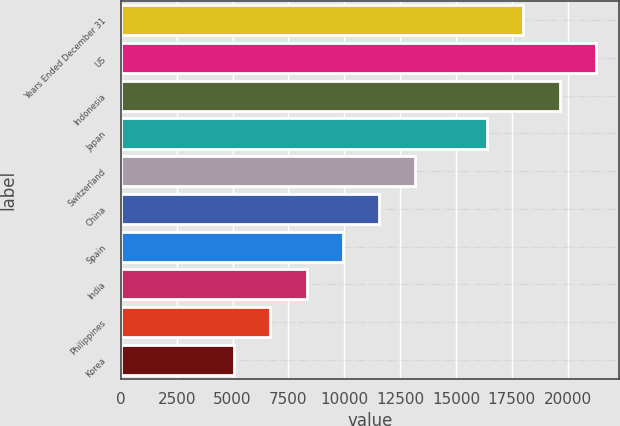Convert chart to OTSL. <chart><loc_0><loc_0><loc_500><loc_500><bar_chart><fcel>Years Ended December 31<fcel>US<fcel>Indonesia<fcel>Japan<fcel>Switzerland<fcel>China<fcel>Spain<fcel>India<fcel>Philippines<fcel>Korea<nl><fcel>18020.7<fcel>21256.1<fcel>19638.4<fcel>16403<fcel>13167.6<fcel>11549.9<fcel>9932.2<fcel>8314.5<fcel>6696.8<fcel>5079.1<nl></chart> 